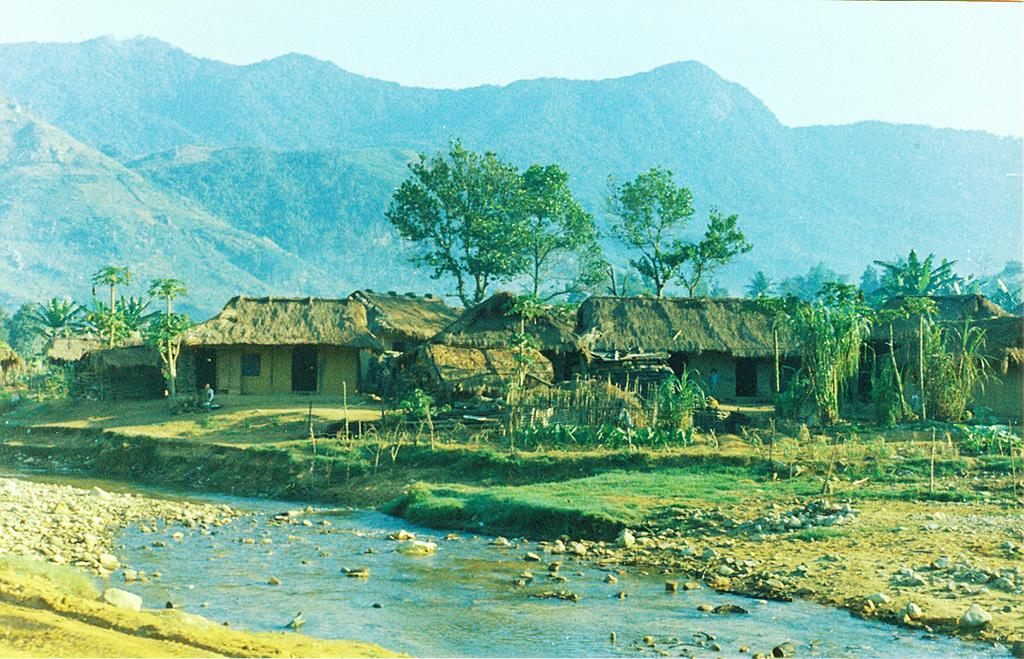What type of vegetation can be seen in the image? There are trees in the image. What else can be seen on the ground in the image? There is grass in the image. What type of structures are present in the image? There are houses in the image. What natural feature can be seen in the image? There is water visible in the image. What is visible in the background of the image? There is a mountain in the background of the image. What type of cap is the mountain wearing in the image? There is no cap present on the mountain in the image. What is the profit margin of the trees in the image? There is no profit margin associated with the trees in the image, as they are not involved in any commercial activity. 